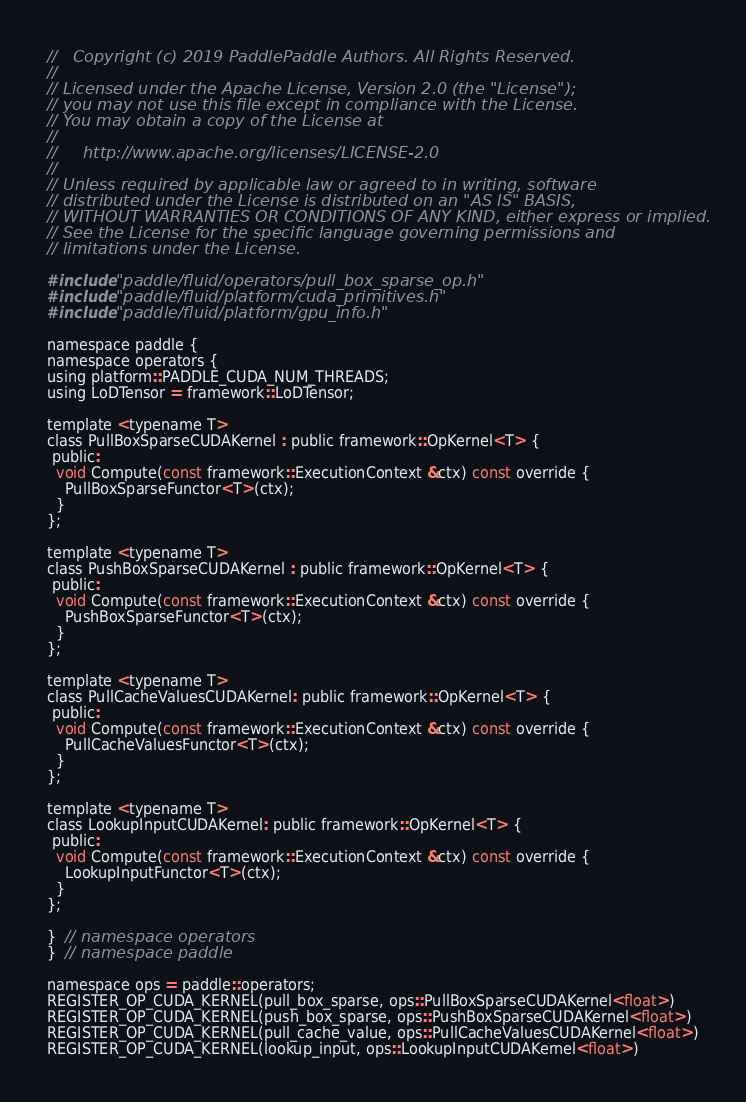Convert code to text. <code><loc_0><loc_0><loc_500><loc_500><_Cuda_>//   Copyright (c) 2019 PaddlePaddle Authors. All Rights Reserved.
//
// Licensed under the Apache License, Version 2.0 (the "License");
// you may not use this file except in compliance with the License.
// You may obtain a copy of the License at
//
//     http://www.apache.org/licenses/LICENSE-2.0
//
// Unless required by applicable law or agreed to in writing, software
// distributed under the License is distributed on an "AS IS" BASIS,
// WITHOUT WARRANTIES OR CONDITIONS OF ANY KIND, either express or implied.
// See the License for the specific language governing permissions and
// limitations under the License.

#include "paddle/fluid/operators/pull_box_sparse_op.h"
#include "paddle/fluid/platform/cuda_primitives.h"
#include "paddle/fluid/platform/gpu_info.h"

namespace paddle {
namespace operators {
using platform::PADDLE_CUDA_NUM_THREADS;
using LoDTensor = framework::LoDTensor;

template <typename T>
class PullBoxSparseCUDAKernel : public framework::OpKernel<T> {
 public:
  void Compute(const framework::ExecutionContext &ctx) const override {
    PullBoxSparseFunctor<T>(ctx);
  }
};

template <typename T>
class PushBoxSparseCUDAKernel : public framework::OpKernel<T> {
 public:
  void Compute(const framework::ExecutionContext &ctx) const override {
    PushBoxSparseFunctor<T>(ctx);
  }
};

template <typename T>
class PullCacheValuesCUDAKernel: public framework::OpKernel<T> {
 public:
  void Compute(const framework::ExecutionContext &ctx) const override {
    PullCacheValuesFunctor<T>(ctx);
  }
};

template <typename T>
class LookupInputCUDAKernel: public framework::OpKernel<T> {
 public:
  void Compute(const framework::ExecutionContext &ctx) const override {
    LookupInputFunctor<T>(ctx);
  }
};

}  // namespace operators
}  // namespace paddle

namespace ops = paddle::operators;
REGISTER_OP_CUDA_KERNEL(pull_box_sparse, ops::PullBoxSparseCUDAKernel<float>)
REGISTER_OP_CUDA_KERNEL(push_box_sparse, ops::PushBoxSparseCUDAKernel<float>)
REGISTER_OP_CUDA_KERNEL(pull_cache_value, ops::PullCacheValuesCUDAKernel<float>)
REGISTER_OP_CUDA_KERNEL(lookup_input, ops::LookupInputCUDAKernel<float>)
</code> 